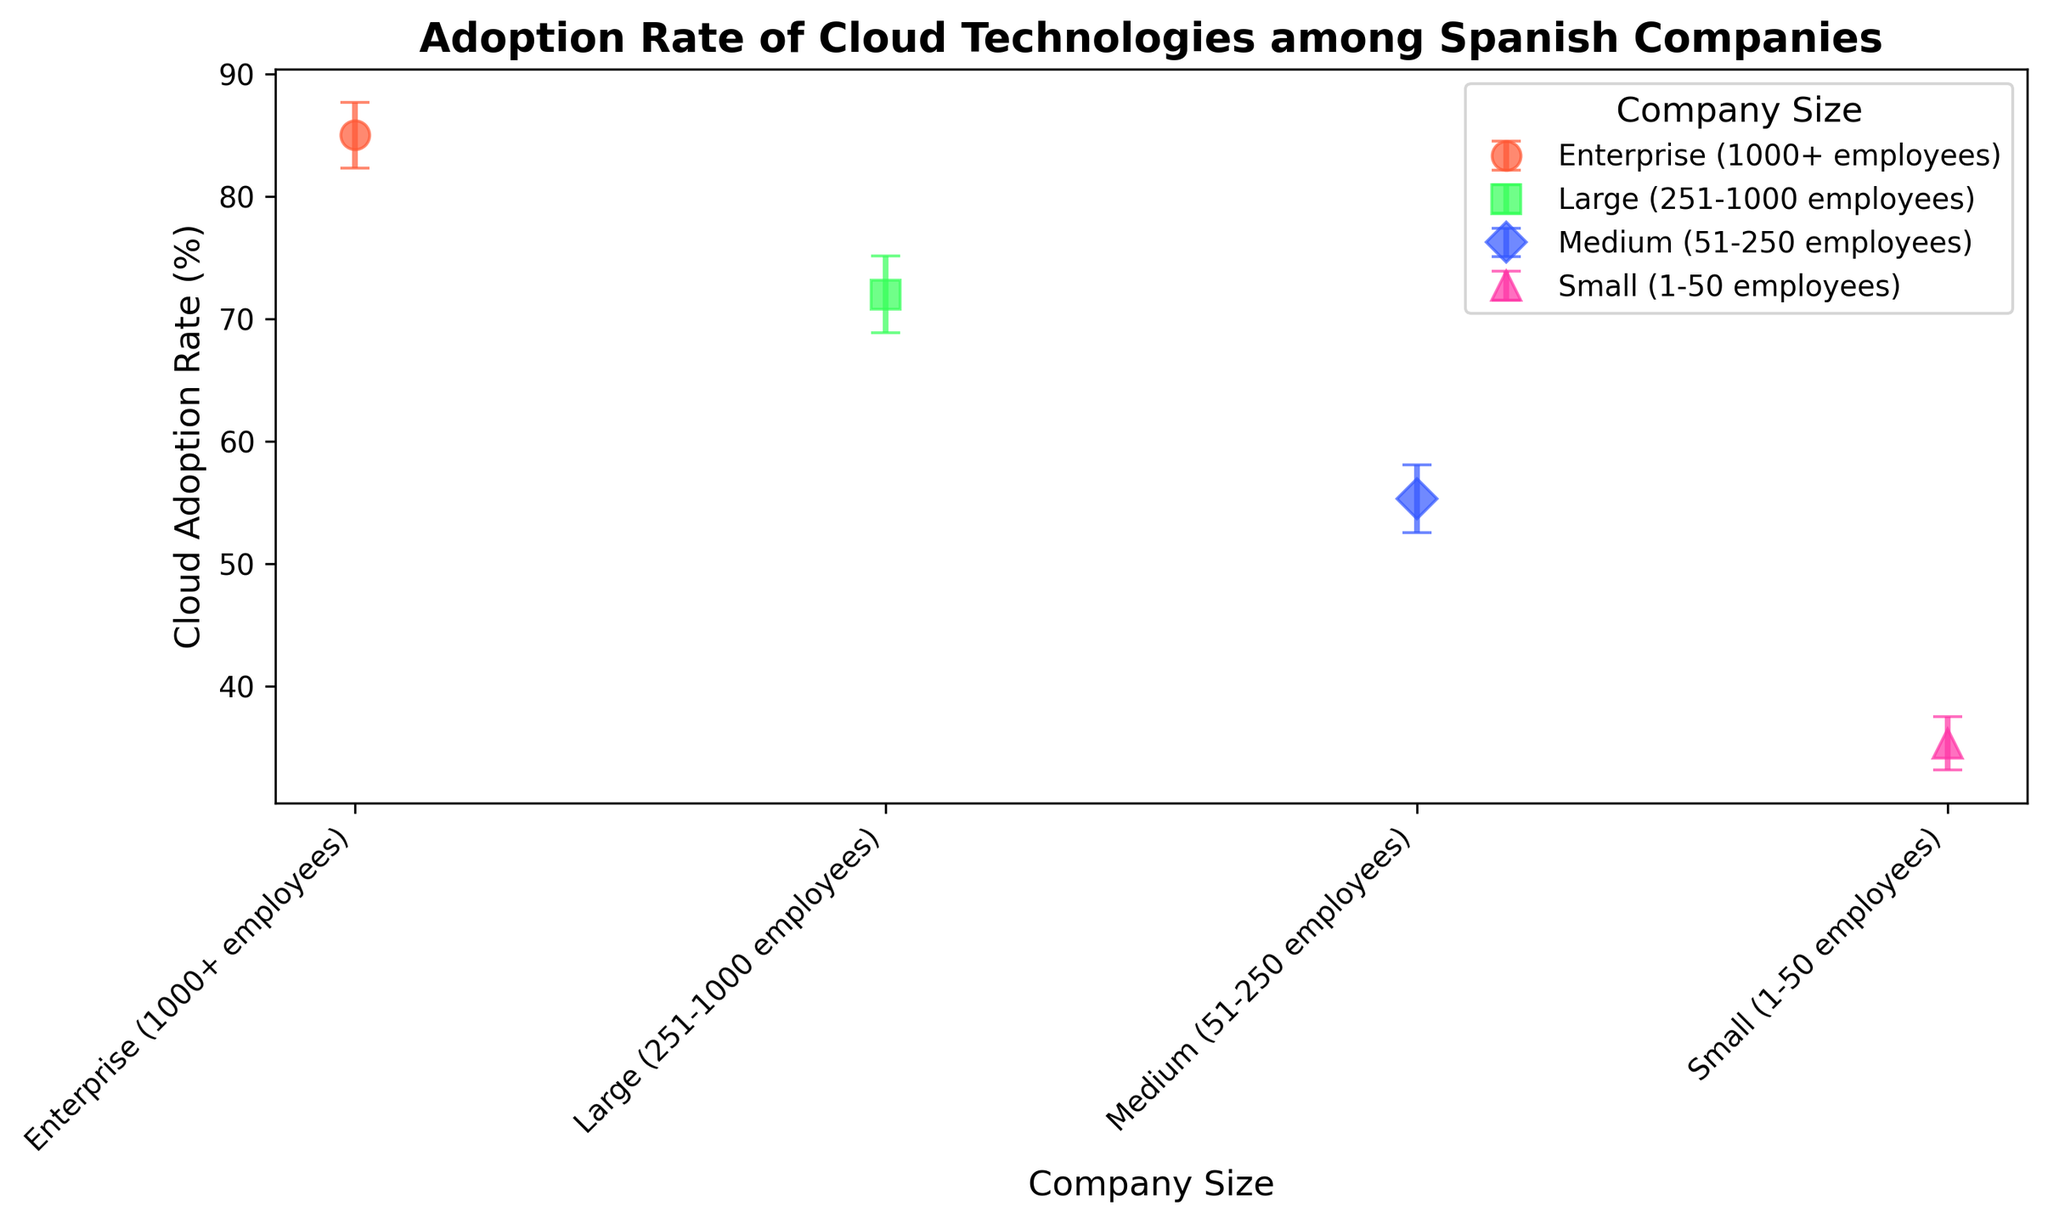What is the cloud adoption rate for medium-sized companies? The medium-sized companies' cloud adoption rate is indicated by the corresponding data point on the x-axis labeled "Medium (51-250 employees)".
Answer: 55% Which company size has the highest average cloud adoption rate? By visually comparing the heights of the points on the y-axis, the point for "Enterprise (1000+ employees)" is the highest.
Answer: Enterprise (1000+ employees) Which age group shows the largest error margin? By observing the error bars, the widest error bar corresponds to the large companies (251-1000 employees).
Answer: Large (251-1000 employees) What is the average cloud adoption rate of the small and medium-sized companies together? The cloud adoption rates for small and medium-sized companies are approximately 35% and 55% respectively. The average is calculated as (35 + 55) / 2 = 45%.
Answer: 45% Compare the cloud adoption rate between large and enterprise companies. Which is higher and by how much? The adoption rate for large companies is approximately 72%, whereas for enterprise companies it is approximately 85%. The difference is 85% - 72% = 13%.
Answer: Enterprise companies have a 13% higher adoption rate What are the cloud adoption rates for the company sizes represented by the color green and red? The green marker represents medium-sized companies with a rate of 55%, and the red marker represents small companies with a rate of 35%.
Answer: 55% and 35% Which company size category shows the smallest cloud adoption rate? Observing the y-axis values, the point for "Small (1-50 employees)" is the lowest.
Answer: Small (1-50 employees) What is the average error margin across all company sizes? The error margins are 2%, 2.5%, 3.5%, and 2.6% respectively for the four company sizes. The average is calculated as (2 + 2.5 + 3.5 + 2.6) / 4 ≈ 2.65%.
Answer: 2.65% Which company size category shows both high cloud adoption rate and low error margin? The "Enterprise (1000+ employees)" category has a high rate of about 85% and a relatively low error margin of 2.6%.
Answer: Enterprise (1000+ employees) What is the visual difference between the markers for small and enterprise companies? The marker for small companies is a red circle, while the marker for enterprise companies is a purple triangle.
Answer: Red circle and purple triangle 